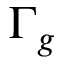Convert formula to latex. <formula><loc_0><loc_0><loc_500><loc_500>\Gamma _ { g }</formula> 